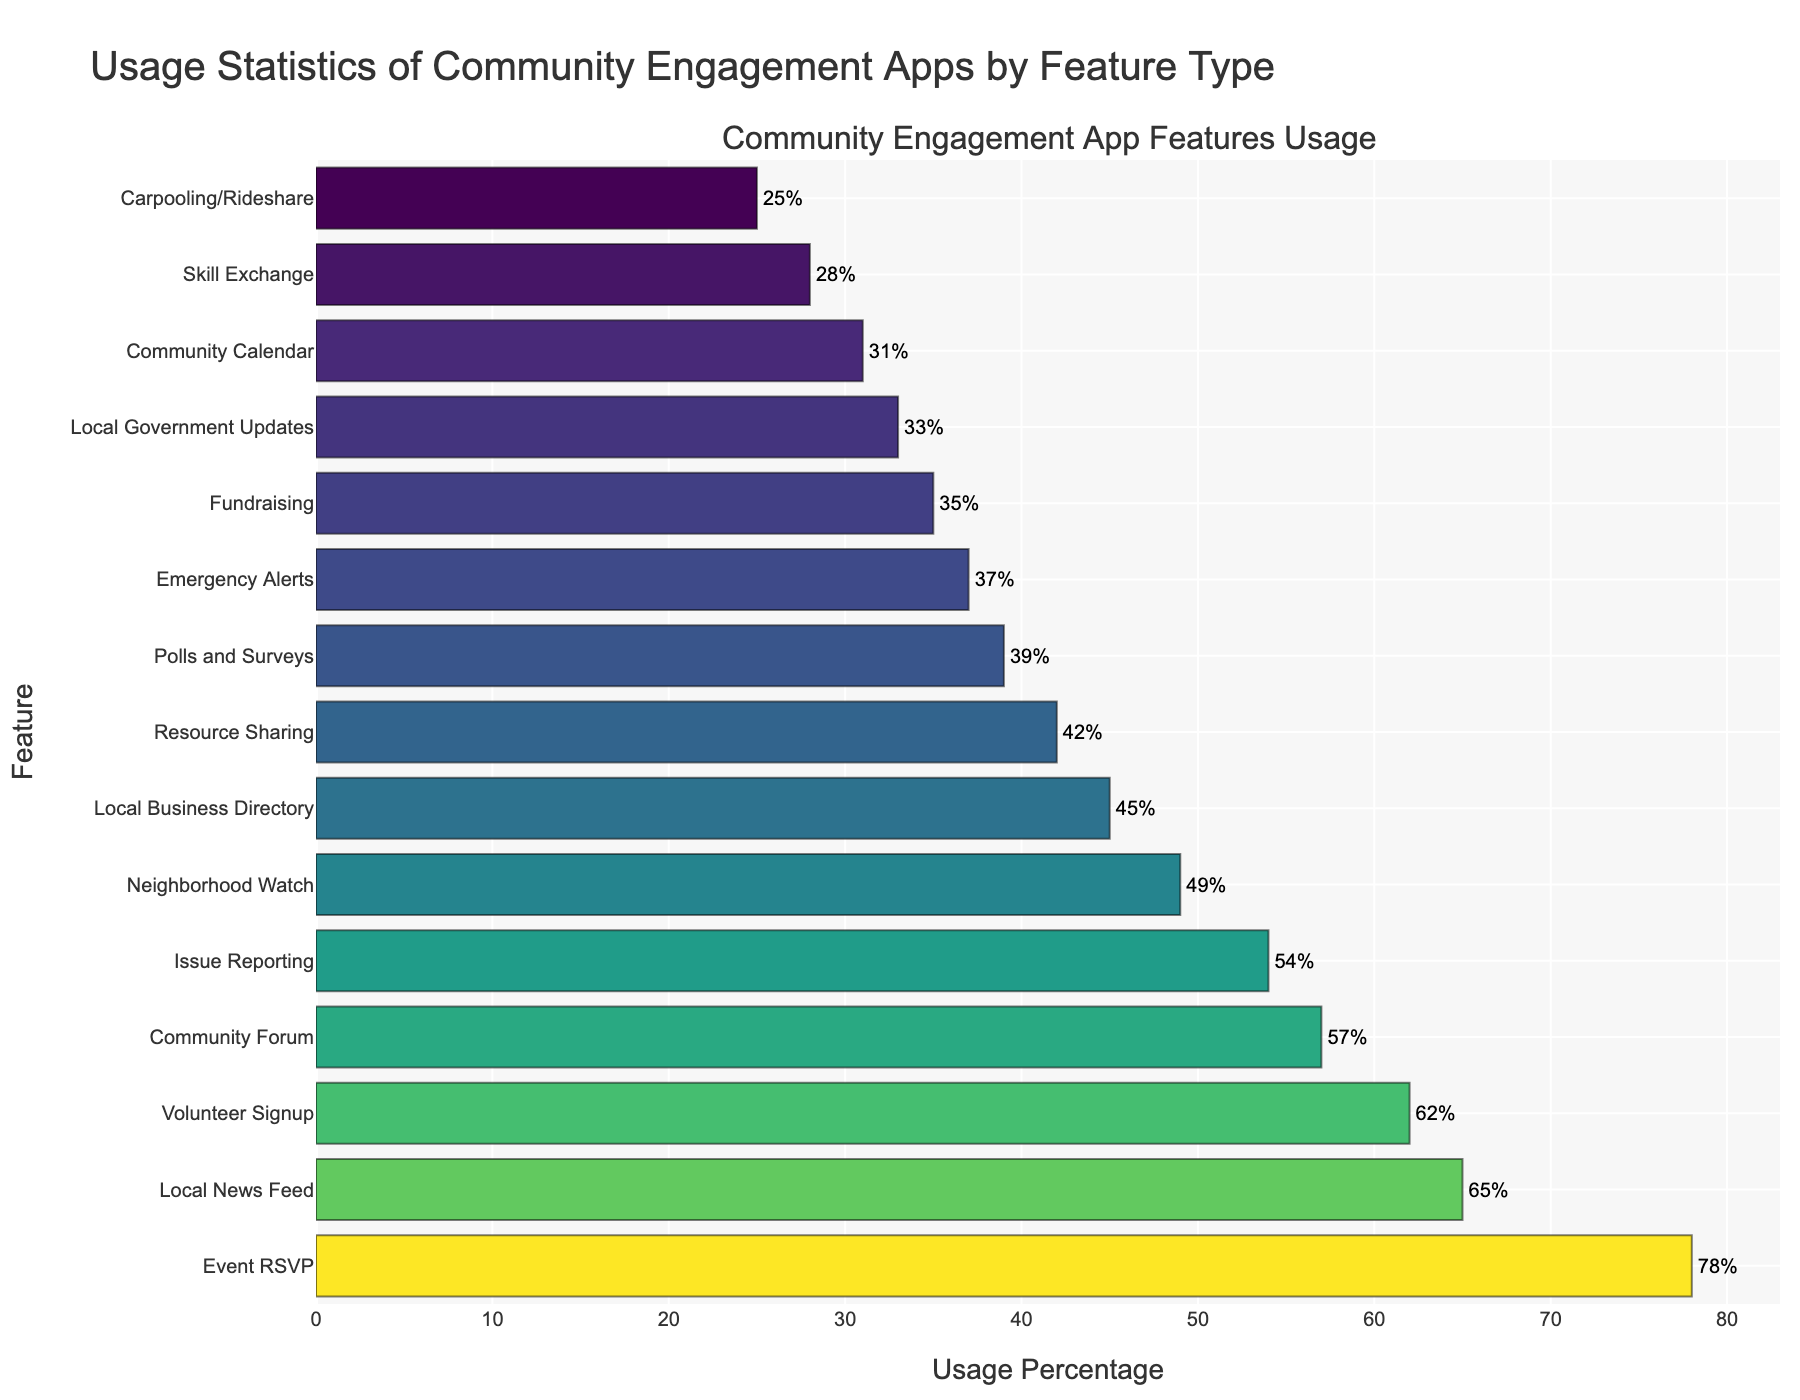What's the most frequently used feature in the community engagement app? The most frequently used feature is the one with the highest Usage Percentage. From the bar chart, "Event RSVP" tops the list at 78%.
Answer: Event RSVP What's the difference in usage percentage between the "Local News Feed" and the "Emergency Alerts" features? The "Local News Feed" has a Usage Percentage of 65%, while "Emergency Alerts" is at 37%. The difference is 65% - 37% = 28%.
Answer: 28% Which feature has a Usage Percentage of less than 50% but more than 30%? Features with Usage Percentages between 30% and 50% are "Neighborhood Watch" (49%), "Local Business Directory" (45%), "Resource Sharing" (42%), "Polls and Surveys" (39%), "Emergency Alerts" (37%), "Fundraising" (35%), and "Local Government Updates" (33%).
Answer: Neighborhood Watch, Local Business Directory, Resource Sharing, Polls and Surveys, Emergency Alerts, Fundraising, Local Government Updates What's the average Usage Percentage of the top three most used features? The top three features are "Event RSVP" (78%), "Local News Feed" (65%), and "Volunteer Signup" (62%). Their average Usage Percentage is (78 + 65 + 62) / 3 = 68.33%.
Answer: 68.33% How many features have a Usage Percentage higher than 40%? From the bar chart, the features with Usage Percentages higher than 40% are "Event RSVP" (78%), "Local News Feed" (65%), "Volunteer Signup" (62%), "Community Forum" (57%), "Issue Reporting" (54%), "Neighborhood Watch" (49%), "Local Business Directory" (45%), and "Resource Sharing" (42%). There are 8 such features.
Answer: 8 Compare the Usage Percentages of "Fundraising" and "Community Calendar". "Fundraising" has a Usage Percentage of 35%, while "Community Calendar" has a Usage Percentage of 31%. Therefore, "Fundraising" is used more often than "Community Calendar" by 35% - 31% = 4%.
Answer: Fundraising is more used by 4% What is the least used feature in the community engagement app? The least used feature is the one with the lowest Usage Percentage. According to the bar chart, "Carpooling/Rideshare" is the least used at 25%.
Answer: Carpooling/Rideshare Which features have a Usage Percentage between 60% and 70%? Features in this range are "Local News Feed" (65%) and "Volunteer Signup" (62%).
Answer: Local News Feed, Volunteer Signup 